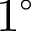<formula> <loc_0><loc_0><loc_500><loc_500>1 ^ { \circ }</formula> 